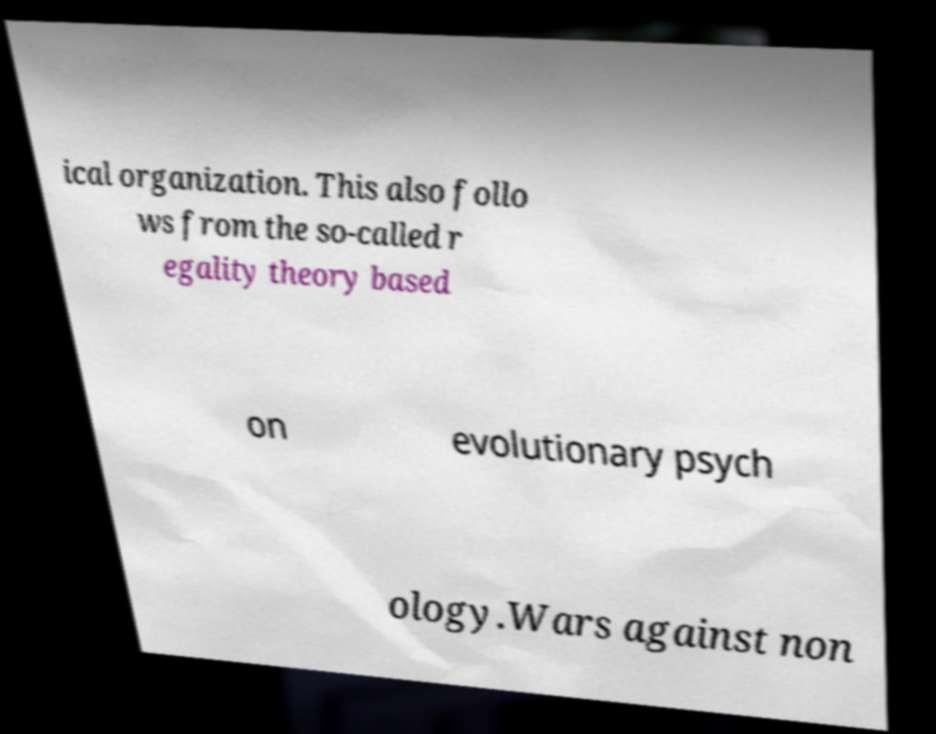For documentation purposes, I need the text within this image transcribed. Could you provide that? ical organization. This also follo ws from the so-called r egality theory based on evolutionary psych ology.Wars against non 